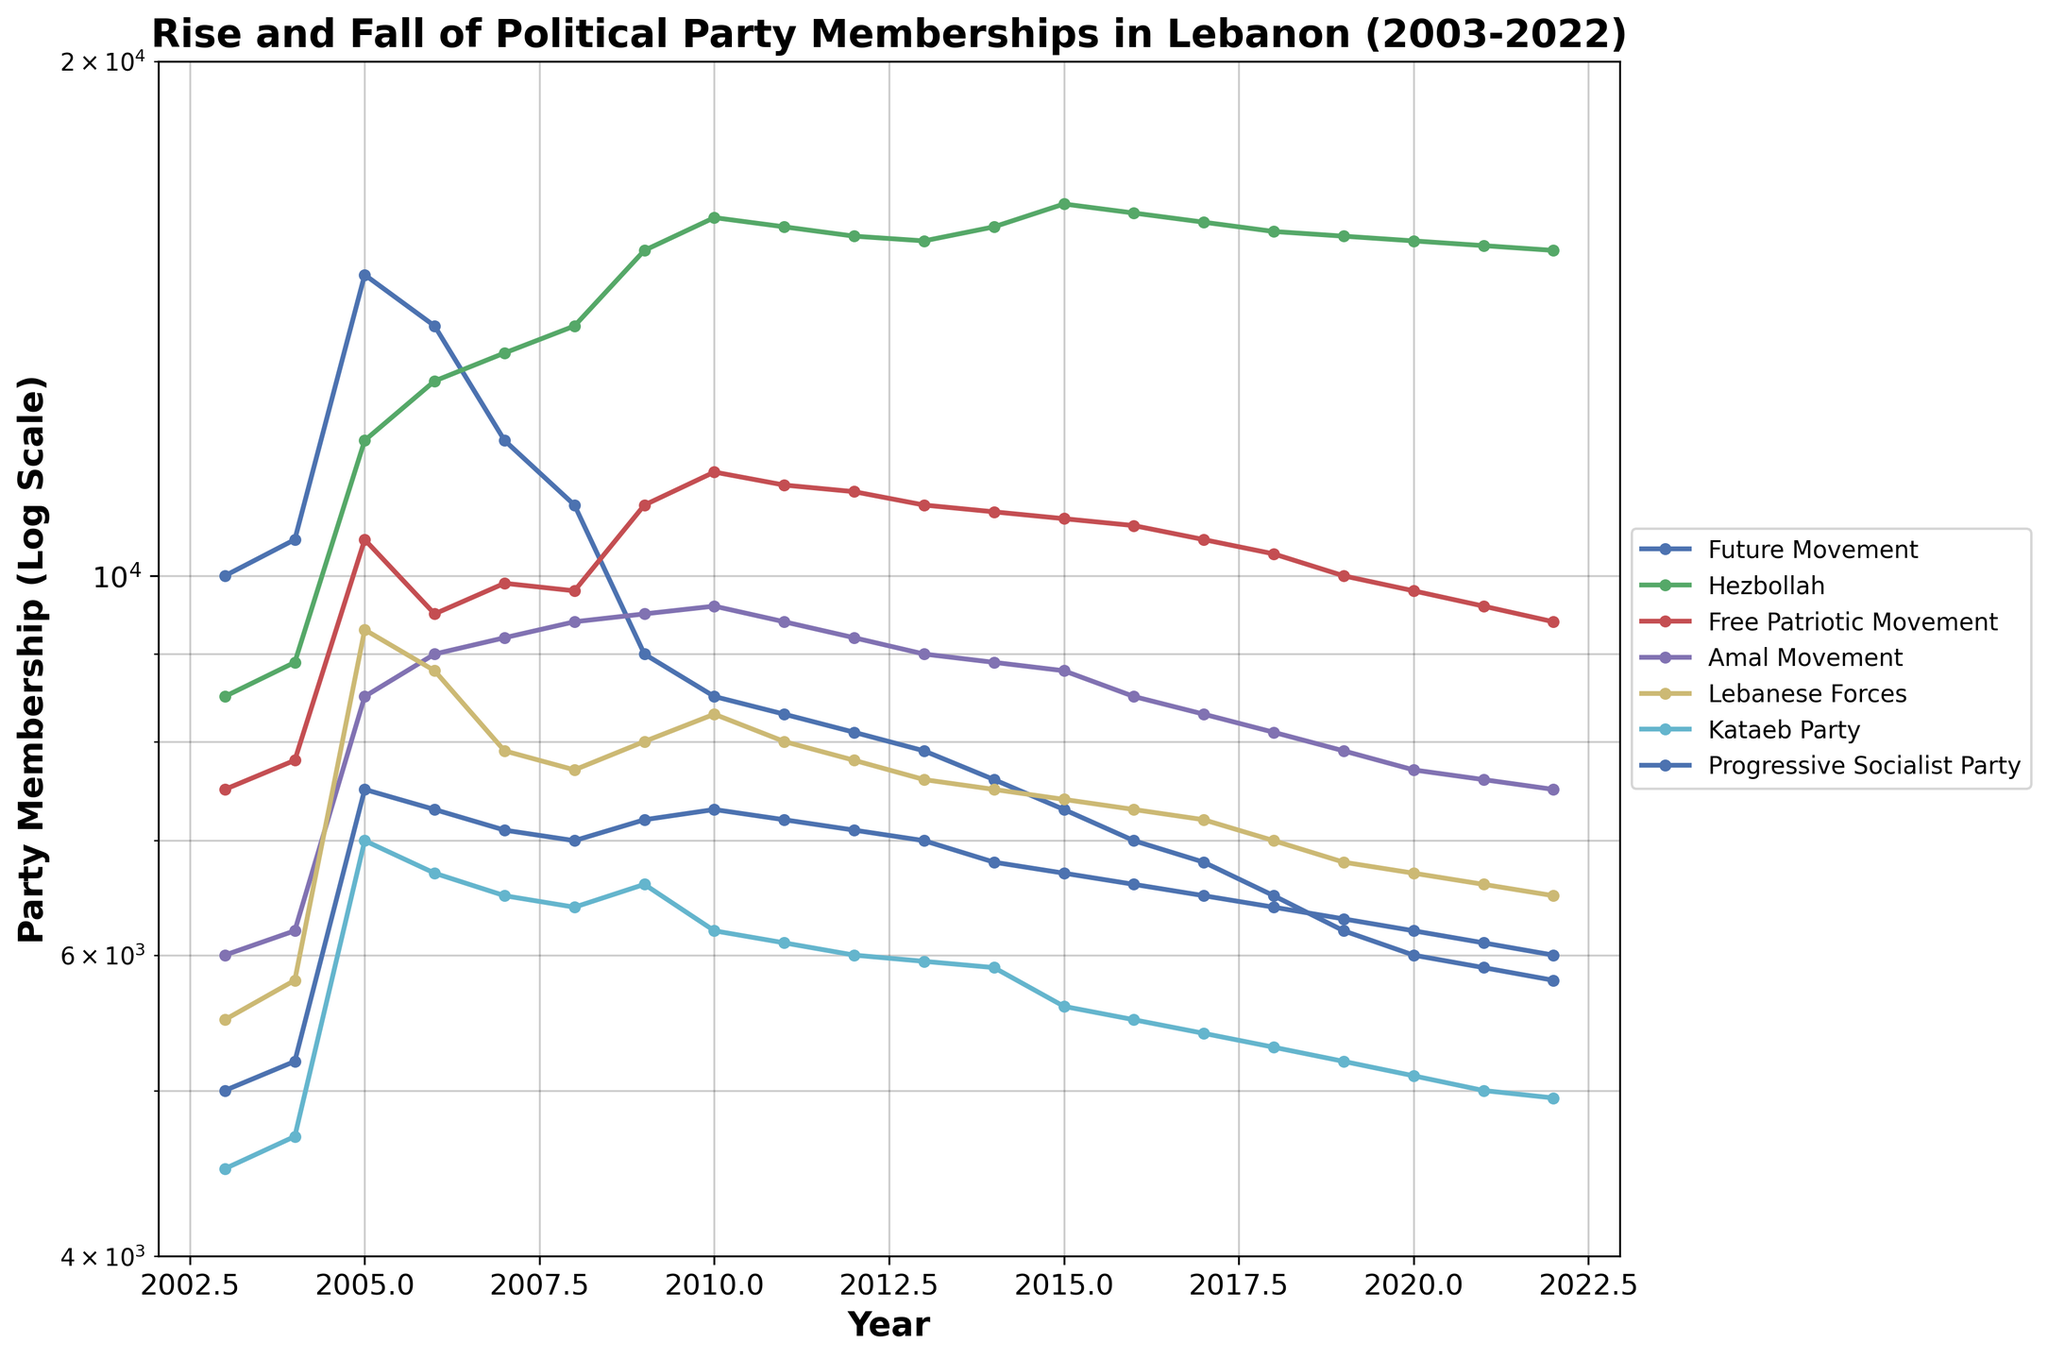What's the title of the figure? The title is usually displayed at the top of the figure. Here, it reads "Rise and Fall of Political Party Memberships in Lebanon (2003-2022)."
Answer: Rise and Fall of Political Party Memberships in Lebanon (2003-2022) What is the y-axis scale, and what are its minimum and maximum values? The y-axis is on a log scale, which means it increases exponentially. The minimum value is 4000, and the maximum value is 20000.
Answer: Logarithmic scale, 4000 to 20000 Which political party had the highest membership in 2022 and what was the value? By looking at the 2022 data point for each line and comparing them, Hezbollah had the highest membership at 15500.
Answer: Hezbollah, 15500 How did the membership of the Future Movement change over the 20 years? Follow the Future Movement line from the start in 2003 (10000 members) to the end in 2022 (5800 members). Observe that it generally decreased over the years.
Answer: Decreased from 10000 to 5800 Which political party showed a stark increase in membership around 2009-2010? Check the data lines for a steep upward trend in those years. Hezbollah demonstrates a sharp increase, going from 15500 in 2009 to 16200 in 2010.
Answer: Hezbollah What was the trend for the Progressive Socialist Party membership over the 20 years? Follow the line representing the Progressive Socialist Party from 2003 (5000 members) to 2022 (6000 members). It shows minor fluctuations but remains relatively stable.
Answer: Relatively stable Which two political parties had nearly equal memberships around 2015? Look for lines that are close to each other around 2015. The Free Patriotic Movement (10800) and the Amal Movement (8800) had memberships close to one another.
Answer: Free Patriotic Movement and Amal Movement What is the most noticeable trend for the Kataeb Party membership over time? Observe the Kataeb Party's line, starting at 4500 in 2003 and ending at 4950 in 2022. There was a general increasing trend, with minor fluctuations.
Answer: General increasing trend What was the membership value of the Lebanese Forces in 2005, and how did it change by 2022? Look at the data points for the Lebanese Forces in 2005 (9300 members) and compare it to 2022 (6500 members). There was a decline.
Answer: From 9300 to 6500 Which year did the Amal Movement reach its peak membership value, and what was the value? Find the highest point on the line for the Amal Movement and check the corresponding year. The year is 2010 with a value of 9600.
Answer: 2010, 9600 